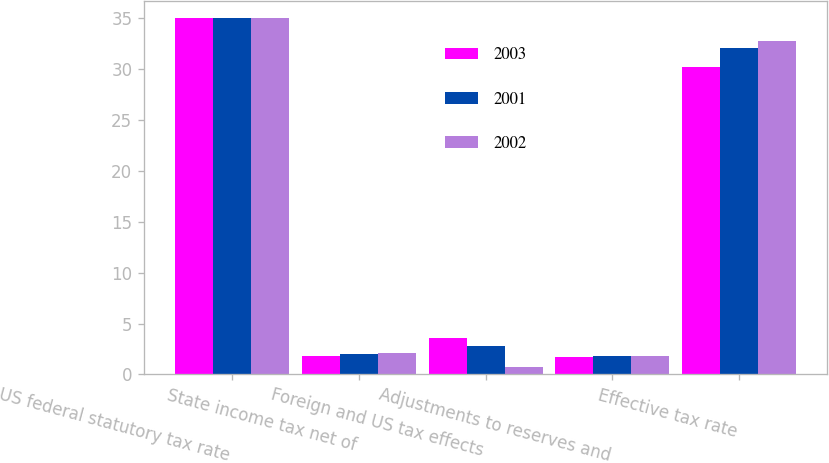<chart> <loc_0><loc_0><loc_500><loc_500><stacked_bar_chart><ecel><fcel>US federal statutory tax rate<fcel>State income tax net of<fcel>Foreign and US tax effects<fcel>Adjustments to reserves and<fcel>Effective tax rate<nl><fcel>2003<fcel>35<fcel>1.8<fcel>3.6<fcel>1.7<fcel>30.2<nl><fcel>2001<fcel>35<fcel>2<fcel>2.8<fcel>1.8<fcel>32.1<nl><fcel>2002<fcel>35<fcel>2.1<fcel>0.7<fcel>1.8<fcel>32.8<nl></chart> 